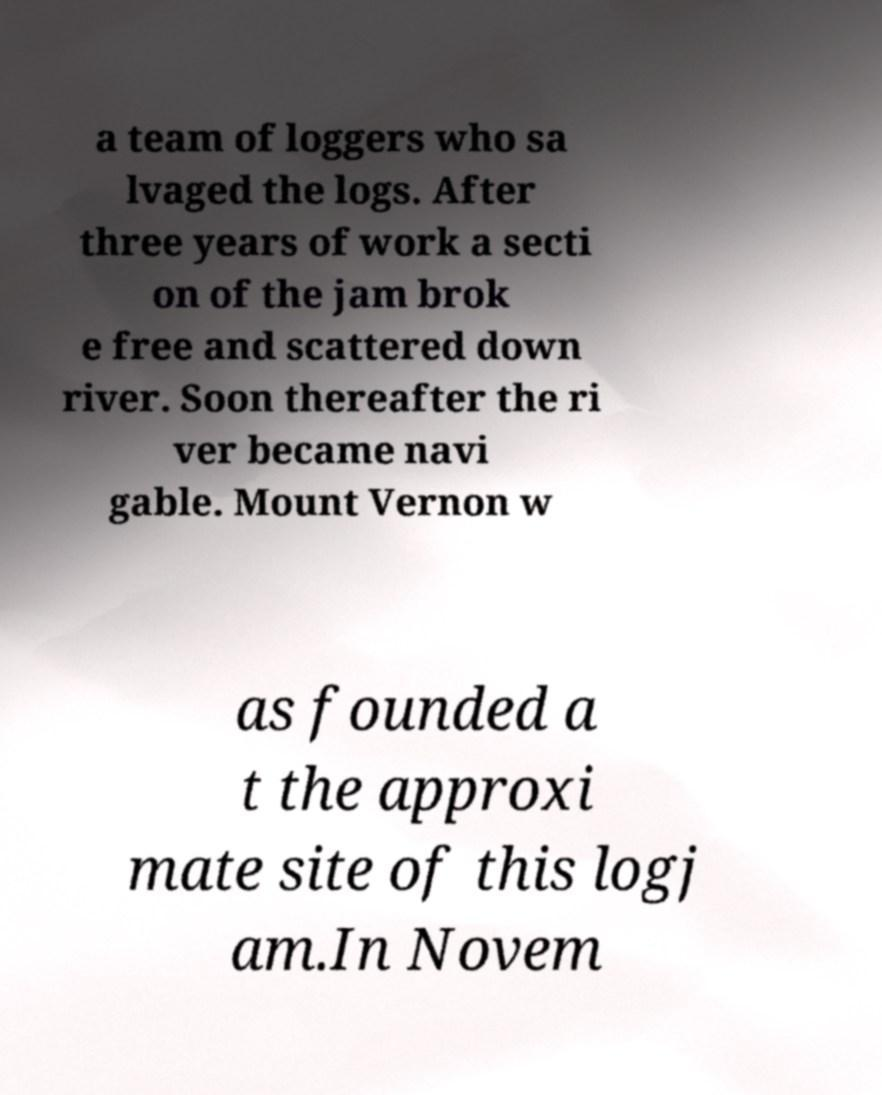I need the written content from this picture converted into text. Can you do that? a team of loggers who sa lvaged the logs. After three years of work a secti on of the jam brok e free and scattered down river. Soon thereafter the ri ver became navi gable. Mount Vernon w as founded a t the approxi mate site of this logj am.In Novem 